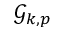Convert formula to latex. <formula><loc_0><loc_0><loc_500><loc_500>\mathcal { G } _ { k , p }</formula> 